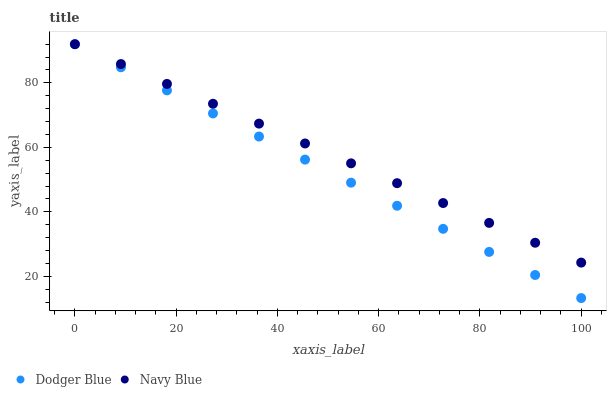Does Dodger Blue have the minimum area under the curve?
Answer yes or no. Yes. Does Navy Blue have the maximum area under the curve?
Answer yes or no. Yes. Does Dodger Blue have the maximum area under the curve?
Answer yes or no. No. Is Navy Blue the smoothest?
Answer yes or no. Yes. Is Dodger Blue the roughest?
Answer yes or no. Yes. Is Dodger Blue the smoothest?
Answer yes or no. No. Does Dodger Blue have the lowest value?
Answer yes or no. Yes. Does Dodger Blue have the highest value?
Answer yes or no. Yes. Does Dodger Blue intersect Navy Blue?
Answer yes or no. Yes. Is Dodger Blue less than Navy Blue?
Answer yes or no. No. Is Dodger Blue greater than Navy Blue?
Answer yes or no. No. 